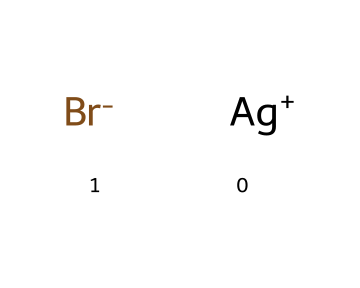What is the charge of the silver ion in this compound? The SMILES representation shows [Ag+], indicating that the silver ion has a positive charge.
Answer: positive How many total atoms are present in this compound? This compound consists of one silver atom (Ag) and one bromine atom (Br), totaling to two atoms.
Answer: 2 What type of bond is formed between silver and bromine? The silver ion ([Ag+]) and the bromine ion ([Br-]) are held together by an ionic bond due to their opposite charges.
Answer: ionic What overall charge does this compound have? The compound is made up of one Ag+ and one Br-, which balances out to a net neutral charge.
Answer: neutral Is AgBr considered a photoreactive compound? Silver bromide (AgBr) is known for its photosensitivity, thereby making it a photoreactive compound used in photography.
Answer: yes Why is silver bromide important in traditional photography? Silver bromide's photosensitivity allows for the development of images when exposed to light, making it essential in photographic processes.
Answer: image development What type of reaction does silver bromide undergo when exposed to light? When exposed to light, silver bromide undergoes a photochemical reaction, leading to the formation of elemental silver and bromine.
Answer: photoreaction 